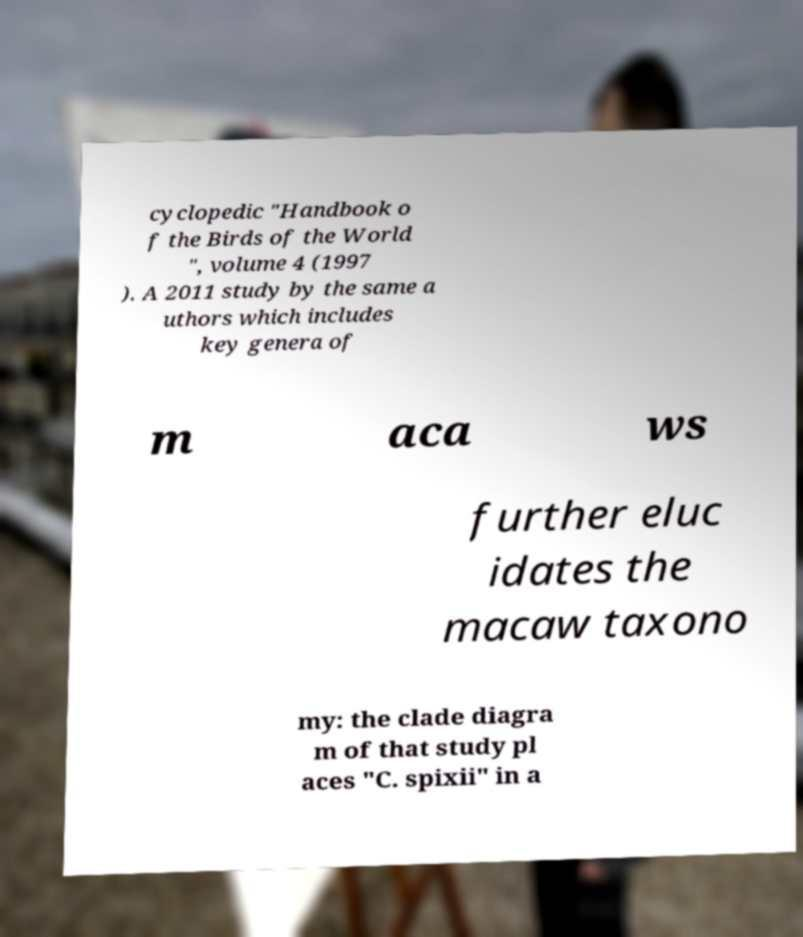There's text embedded in this image that I need extracted. Can you transcribe it verbatim? cyclopedic "Handbook o f the Birds of the World ", volume 4 (1997 ). A 2011 study by the same a uthors which includes key genera of m aca ws further eluc idates the macaw taxono my: the clade diagra m of that study pl aces "C. spixii" in a 